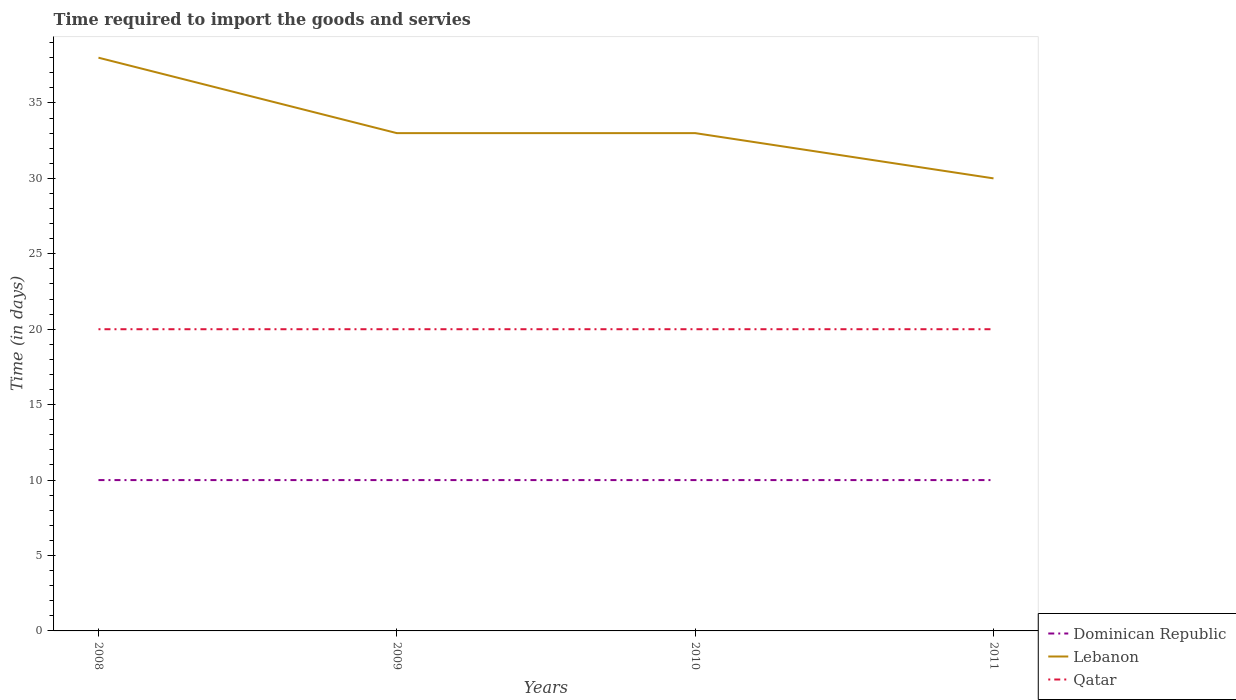How many different coloured lines are there?
Provide a succinct answer. 3. Does the line corresponding to Lebanon intersect with the line corresponding to Dominican Republic?
Offer a very short reply. No. Across all years, what is the maximum number of days required to import the goods and services in Dominican Republic?
Keep it short and to the point. 10. What is the difference between the highest and the second highest number of days required to import the goods and services in Lebanon?
Your answer should be compact. 8. Is the number of days required to import the goods and services in Lebanon strictly greater than the number of days required to import the goods and services in Dominican Republic over the years?
Your answer should be very brief. No. How many lines are there?
Your response must be concise. 3. How many years are there in the graph?
Your answer should be compact. 4. What is the difference between two consecutive major ticks on the Y-axis?
Your response must be concise. 5. Does the graph contain any zero values?
Keep it short and to the point. No. Does the graph contain grids?
Make the answer very short. No. How many legend labels are there?
Your answer should be compact. 3. How are the legend labels stacked?
Give a very brief answer. Vertical. What is the title of the graph?
Your answer should be very brief. Time required to import the goods and servies. Does "Turkey" appear as one of the legend labels in the graph?
Ensure brevity in your answer.  No. What is the label or title of the X-axis?
Offer a very short reply. Years. What is the label or title of the Y-axis?
Your answer should be compact. Time (in days). What is the Time (in days) in Qatar in 2008?
Your answer should be very brief. 20. What is the Time (in days) of Dominican Republic in 2009?
Your answer should be compact. 10. What is the Time (in days) in Dominican Republic in 2010?
Give a very brief answer. 10. What is the Time (in days) in Lebanon in 2010?
Your response must be concise. 33. What is the Time (in days) in Dominican Republic in 2011?
Provide a succinct answer. 10. What is the Time (in days) of Lebanon in 2011?
Give a very brief answer. 30. Across all years, what is the maximum Time (in days) of Lebanon?
Offer a very short reply. 38. Across all years, what is the minimum Time (in days) in Dominican Republic?
Provide a succinct answer. 10. Across all years, what is the minimum Time (in days) in Qatar?
Keep it short and to the point. 20. What is the total Time (in days) of Lebanon in the graph?
Provide a short and direct response. 134. What is the total Time (in days) in Qatar in the graph?
Your response must be concise. 80. What is the difference between the Time (in days) of Lebanon in 2008 and that in 2009?
Make the answer very short. 5. What is the difference between the Time (in days) in Qatar in 2008 and that in 2009?
Offer a very short reply. 0. What is the difference between the Time (in days) of Dominican Republic in 2008 and that in 2010?
Ensure brevity in your answer.  0. What is the difference between the Time (in days) in Lebanon in 2008 and that in 2010?
Your answer should be very brief. 5. What is the difference between the Time (in days) of Lebanon in 2008 and that in 2011?
Make the answer very short. 8. What is the difference between the Time (in days) of Dominican Republic in 2009 and that in 2010?
Make the answer very short. 0. What is the difference between the Time (in days) in Dominican Republic in 2009 and that in 2011?
Your response must be concise. 0. What is the difference between the Time (in days) of Lebanon in 2009 and that in 2011?
Provide a succinct answer. 3. What is the difference between the Time (in days) in Qatar in 2009 and that in 2011?
Provide a succinct answer. 0. What is the difference between the Time (in days) in Dominican Republic in 2010 and that in 2011?
Ensure brevity in your answer.  0. What is the difference between the Time (in days) in Dominican Republic in 2008 and the Time (in days) in Qatar in 2009?
Your response must be concise. -10. What is the difference between the Time (in days) of Dominican Republic in 2008 and the Time (in days) of Lebanon in 2010?
Keep it short and to the point. -23. What is the difference between the Time (in days) of Dominican Republic in 2008 and the Time (in days) of Qatar in 2010?
Provide a short and direct response. -10. What is the difference between the Time (in days) of Lebanon in 2008 and the Time (in days) of Qatar in 2010?
Make the answer very short. 18. What is the difference between the Time (in days) in Dominican Republic in 2008 and the Time (in days) in Qatar in 2011?
Give a very brief answer. -10. What is the difference between the Time (in days) of Dominican Republic in 2009 and the Time (in days) of Lebanon in 2010?
Provide a succinct answer. -23. What is the difference between the Time (in days) in Dominican Republic in 2009 and the Time (in days) in Lebanon in 2011?
Keep it short and to the point. -20. What is the difference between the Time (in days) in Lebanon in 2009 and the Time (in days) in Qatar in 2011?
Make the answer very short. 13. What is the difference between the Time (in days) of Dominican Republic in 2010 and the Time (in days) of Qatar in 2011?
Your response must be concise. -10. What is the difference between the Time (in days) in Lebanon in 2010 and the Time (in days) in Qatar in 2011?
Give a very brief answer. 13. What is the average Time (in days) of Dominican Republic per year?
Your response must be concise. 10. What is the average Time (in days) in Lebanon per year?
Offer a very short reply. 33.5. What is the average Time (in days) in Qatar per year?
Ensure brevity in your answer.  20. In the year 2008, what is the difference between the Time (in days) in Dominican Republic and Time (in days) in Qatar?
Keep it short and to the point. -10. In the year 2008, what is the difference between the Time (in days) in Lebanon and Time (in days) in Qatar?
Your response must be concise. 18. In the year 2009, what is the difference between the Time (in days) in Dominican Republic and Time (in days) in Lebanon?
Your answer should be very brief. -23. In the year 2009, what is the difference between the Time (in days) of Dominican Republic and Time (in days) of Qatar?
Keep it short and to the point. -10. In the year 2010, what is the difference between the Time (in days) in Dominican Republic and Time (in days) in Qatar?
Your answer should be compact. -10. In the year 2011, what is the difference between the Time (in days) in Dominican Republic and Time (in days) in Lebanon?
Your answer should be very brief. -20. In the year 2011, what is the difference between the Time (in days) in Lebanon and Time (in days) in Qatar?
Offer a very short reply. 10. What is the ratio of the Time (in days) in Lebanon in 2008 to that in 2009?
Ensure brevity in your answer.  1.15. What is the ratio of the Time (in days) in Lebanon in 2008 to that in 2010?
Your response must be concise. 1.15. What is the ratio of the Time (in days) of Qatar in 2008 to that in 2010?
Give a very brief answer. 1. What is the ratio of the Time (in days) of Lebanon in 2008 to that in 2011?
Your answer should be compact. 1.27. What is the ratio of the Time (in days) of Dominican Republic in 2009 to that in 2010?
Offer a terse response. 1. What is the ratio of the Time (in days) of Qatar in 2009 to that in 2011?
Your answer should be very brief. 1. What is the ratio of the Time (in days) in Dominican Republic in 2010 to that in 2011?
Provide a short and direct response. 1. What is the difference between the highest and the second highest Time (in days) in Dominican Republic?
Your response must be concise. 0. What is the difference between the highest and the second highest Time (in days) of Lebanon?
Offer a very short reply. 5. What is the difference between the highest and the lowest Time (in days) in Dominican Republic?
Give a very brief answer. 0. What is the difference between the highest and the lowest Time (in days) of Lebanon?
Provide a short and direct response. 8. 